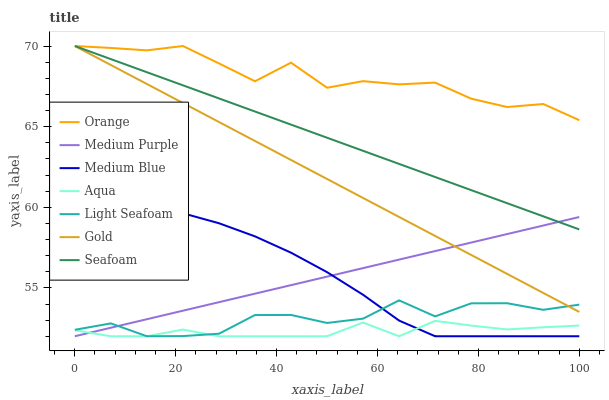Does Medium Blue have the minimum area under the curve?
Answer yes or no. No. Does Medium Blue have the maximum area under the curve?
Answer yes or no. No. Is Medium Blue the smoothest?
Answer yes or no. No. Is Medium Blue the roughest?
Answer yes or no. No. Does Seafoam have the lowest value?
Answer yes or no. No. Does Medium Blue have the highest value?
Answer yes or no. No. Is Medium Blue less than Seafoam?
Answer yes or no. Yes. Is Seafoam greater than Medium Blue?
Answer yes or no. Yes. Does Medium Blue intersect Seafoam?
Answer yes or no. No. 